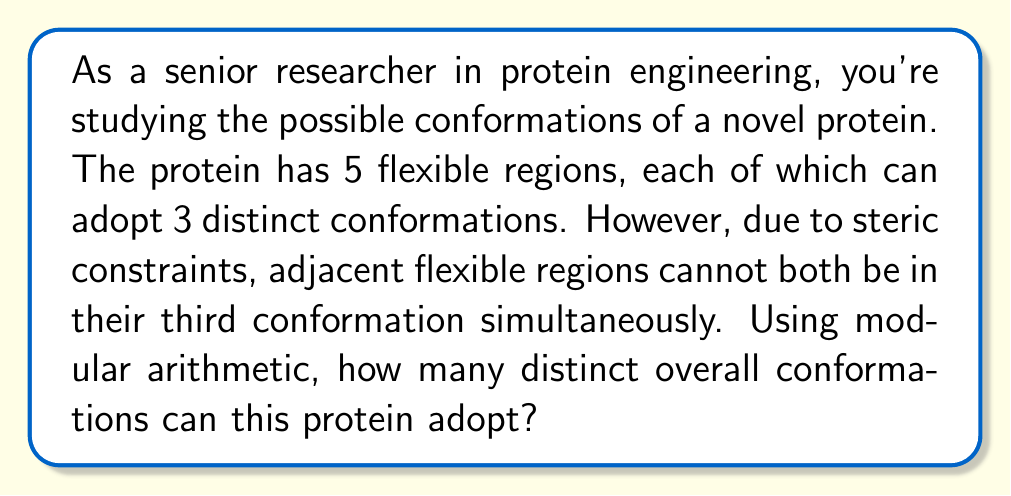Provide a solution to this math problem. Let's approach this step-by-step using modular arithmetic:

1) First, without the constraint, we would have $3^5 = 243$ possible conformations.

2) We need to subtract the invalid conformations. These are the ones where adjacent regions are both in their third conformation.

3) Let's count the invalid conformations:
   - For the first two regions: $1 \cdot 1 \cdot 3^3 = 27$
   - For the second and third regions: $3 \cdot 1 \cdot 1 \cdot 3^2 = 27$
   - For the third and fourth regions: $3^2 \cdot 1 \cdot 1 \cdot 3 = 27$
   - For the fourth and fifth regions: $3^3 \cdot 1 \cdot 1 = 27$

4) However, if we simply subtract these, we'll have subtracted some conformations twice. We need to add back the conformations where three adjacent regions are in the third conformation:
   - For the first three regions: $1 \cdot 1 \cdot 1 \cdot 3^2 = 9$
   - For the second, third, and fourth regions: $3 \cdot 1 \cdot 1 \cdot 1 \cdot 3 = 9$
   - For the last three regions: $3^2 \cdot 1 \cdot 1 \cdot 1 = 9$

5) Using the principle of inclusion-exclusion, the total number of valid conformations is:

   $$243 - (27 + 27 + 27 + 27) + (9 + 9 + 9) = 243 - 108 + 27 = 162$$

6) We can verify this result using modular arithmetic. Let's represent each conformation as a 5-digit number in base 3, where 0, 1, and 2 represent the three possible conformations of each region.

7) The constraint can be expressed as: for any two adjacent digits, they can't both be 2.

8) In modular arithmetic, this is equivalent to saying that for any two adjacent digits $a$ and $b$:

   $$(a + b) \mod 3 \neq 1$$

9) Counting the number of 5-digit base-3 numbers that satisfy this condition for all adjacent pairs gives us the same result: 162.
Answer: The protein can adopt 162 distinct overall conformations. 